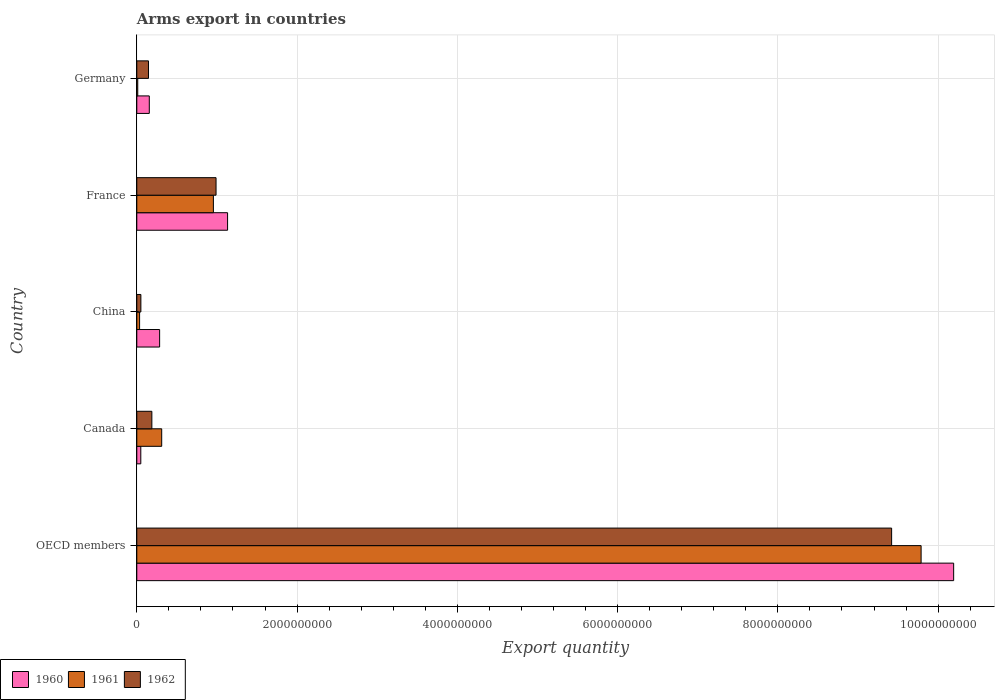How many different coloured bars are there?
Ensure brevity in your answer.  3. Are the number of bars on each tick of the Y-axis equal?
Keep it short and to the point. Yes. How many bars are there on the 1st tick from the bottom?
Provide a succinct answer. 3. In how many cases, is the number of bars for a given country not equal to the number of legend labels?
Ensure brevity in your answer.  0. What is the total arms export in 1960 in OECD members?
Your answer should be compact. 1.02e+1. Across all countries, what is the maximum total arms export in 1960?
Keep it short and to the point. 1.02e+1. Across all countries, what is the minimum total arms export in 1960?
Ensure brevity in your answer.  5.00e+07. In which country was the total arms export in 1962 maximum?
Give a very brief answer. OECD members. What is the total total arms export in 1960 in the graph?
Your response must be concise. 1.18e+1. What is the difference between the total arms export in 1962 in China and that in France?
Provide a short and direct response. -9.38e+08. What is the difference between the total arms export in 1962 in China and the total arms export in 1961 in France?
Your answer should be compact. -9.05e+08. What is the average total arms export in 1961 per country?
Your response must be concise. 2.22e+09. What is the difference between the total arms export in 1962 and total arms export in 1960 in China?
Provide a short and direct response. -2.34e+08. What is the ratio of the total arms export in 1960 in France to that in Germany?
Your answer should be very brief. 7.26. Is the difference between the total arms export in 1962 in Germany and OECD members greater than the difference between the total arms export in 1960 in Germany and OECD members?
Give a very brief answer. Yes. What is the difference between the highest and the second highest total arms export in 1961?
Your answer should be compact. 8.83e+09. What is the difference between the highest and the lowest total arms export in 1962?
Keep it short and to the point. 9.37e+09. In how many countries, is the total arms export in 1962 greater than the average total arms export in 1962 taken over all countries?
Keep it short and to the point. 1. Is the sum of the total arms export in 1960 in China and OECD members greater than the maximum total arms export in 1962 across all countries?
Your answer should be very brief. Yes. Is it the case that in every country, the sum of the total arms export in 1961 and total arms export in 1960 is greater than the total arms export in 1962?
Offer a terse response. Yes. What is the difference between two consecutive major ticks on the X-axis?
Keep it short and to the point. 2.00e+09. Are the values on the major ticks of X-axis written in scientific E-notation?
Make the answer very short. No. What is the title of the graph?
Provide a succinct answer. Arms export in countries. What is the label or title of the X-axis?
Your answer should be very brief. Export quantity. What is the label or title of the Y-axis?
Give a very brief answer. Country. What is the Export quantity in 1960 in OECD members?
Keep it short and to the point. 1.02e+1. What is the Export quantity of 1961 in OECD members?
Your response must be concise. 9.79e+09. What is the Export quantity of 1962 in OECD members?
Make the answer very short. 9.42e+09. What is the Export quantity of 1960 in Canada?
Your answer should be compact. 5.00e+07. What is the Export quantity of 1961 in Canada?
Offer a very short reply. 3.11e+08. What is the Export quantity of 1962 in Canada?
Give a very brief answer. 1.88e+08. What is the Export quantity in 1960 in China?
Ensure brevity in your answer.  2.85e+08. What is the Export quantity of 1961 in China?
Ensure brevity in your answer.  3.50e+07. What is the Export quantity of 1962 in China?
Your answer should be compact. 5.10e+07. What is the Export quantity in 1960 in France?
Keep it short and to the point. 1.13e+09. What is the Export quantity in 1961 in France?
Your response must be concise. 9.56e+08. What is the Export quantity of 1962 in France?
Your answer should be compact. 9.89e+08. What is the Export quantity of 1960 in Germany?
Your response must be concise. 1.56e+08. What is the Export quantity in 1961 in Germany?
Make the answer very short. 1.20e+07. What is the Export quantity of 1962 in Germany?
Ensure brevity in your answer.  1.46e+08. Across all countries, what is the maximum Export quantity in 1960?
Provide a succinct answer. 1.02e+1. Across all countries, what is the maximum Export quantity of 1961?
Your response must be concise. 9.79e+09. Across all countries, what is the maximum Export quantity in 1962?
Give a very brief answer. 9.42e+09. Across all countries, what is the minimum Export quantity of 1961?
Offer a very short reply. 1.20e+07. Across all countries, what is the minimum Export quantity in 1962?
Make the answer very short. 5.10e+07. What is the total Export quantity in 1960 in the graph?
Your response must be concise. 1.18e+1. What is the total Export quantity of 1961 in the graph?
Keep it short and to the point. 1.11e+1. What is the total Export quantity in 1962 in the graph?
Provide a succinct answer. 1.08e+1. What is the difference between the Export quantity of 1960 in OECD members and that in Canada?
Provide a succinct answer. 1.01e+1. What is the difference between the Export quantity of 1961 in OECD members and that in Canada?
Provide a succinct answer. 9.48e+09. What is the difference between the Export quantity of 1962 in OECD members and that in Canada?
Your answer should be very brief. 9.23e+09. What is the difference between the Export quantity in 1960 in OECD members and that in China?
Give a very brief answer. 9.91e+09. What is the difference between the Export quantity of 1961 in OECD members and that in China?
Make the answer very short. 9.75e+09. What is the difference between the Export quantity in 1962 in OECD members and that in China?
Your answer should be compact. 9.37e+09. What is the difference between the Export quantity in 1960 in OECD members and that in France?
Your answer should be very brief. 9.06e+09. What is the difference between the Export quantity of 1961 in OECD members and that in France?
Your answer should be compact. 8.83e+09. What is the difference between the Export quantity of 1962 in OECD members and that in France?
Ensure brevity in your answer.  8.43e+09. What is the difference between the Export quantity in 1960 in OECD members and that in Germany?
Your answer should be very brief. 1.00e+1. What is the difference between the Export quantity of 1961 in OECD members and that in Germany?
Provide a succinct answer. 9.78e+09. What is the difference between the Export quantity of 1962 in OECD members and that in Germany?
Provide a short and direct response. 9.27e+09. What is the difference between the Export quantity in 1960 in Canada and that in China?
Ensure brevity in your answer.  -2.35e+08. What is the difference between the Export quantity in 1961 in Canada and that in China?
Ensure brevity in your answer.  2.76e+08. What is the difference between the Export quantity in 1962 in Canada and that in China?
Keep it short and to the point. 1.37e+08. What is the difference between the Export quantity in 1960 in Canada and that in France?
Provide a succinct answer. -1.08e+09. What is the difference between the Export quantity of 1961 in Canada and that in France?
Give a very brief answer. -6.45e+08. What is the difference between the Export quantity of 1962 in Canada and that in France?
Make the answer very short. -8.01e+08. What is the difference between the Export quantity in 1960 in Canada and that in Germany?
Make the answer very short. -1.06e+08. What is the difference between the Export quantity of 1961 in Canada and that in Germany?
Ensure brevity in your answer.  2.99e+08. What is the difference between the Export quantity in 1962 in Canada and that in Germany?
Your answer should be compact. 4.20e+07. What is the difference between the Export quantity of 1960 in China and that in France?
Ensure brevity in your answer.  -8.48e+08. What is the difference between the Export quantity of 1961 in China and that in France?
Your answer should be compact. -9.21e+08. What is the difference between the Export quantity of 1962 in China and that in France?
Keep it short and to the point. -9.38e+08. What is the difference between the Export quantity of 1960 in China and that in Germany?
Offer a terse response. 1.29e+08. What is the difference between the Export quantity of 1961 in China and that in Germany?
Your answer should be very brief. 2.30e+07. What is the difference between the Export quantity of 1962 in China and that in Germany?
Make the answer very short. -9.50e+07. What is the difference between the Export quantity in 1960 in France and that in Germany?
Your answer should be very brief. 9.77e+08. What is the difference between the Export quantity of 1961 in France and that in Germany?
Your answer should be very brief. 9.44e+08. What is the difference between the Export quantity of 1962 in France and that in Germany?
Ensure brevity in your answer.  8.43e+08. What is the difference between the Export quantity of 1960 in OECD members and the Export quantity of 1961 in Canada?
Keep it short and to the point. 9.88e+09. What is the difference between the Export quantity of 1960 in OECD members and the Export quantity of 1962 in Canada?
Your response must be concise. 1.00e+1. What is the difference between the Export quantity of 1961 in OECD members and the Export quantity of 1962 in Canada?
Provide a short and direct response. 9.60e+09. What is the difference between the Export quantity of 1960 in OECD members and the Export quantity of 1961 in China?
Make the answer very short. 1.02e+1. What is the difference between the Export quantity in 1960 in OECD members and the Export quantity in 1962 in China?
Keep it short and to the point. 1.01e+1. What is the difference between the Export quantity in 1961 in OECD members and the Export quantity in 1962 in China?
Make the answer very short. 9.74e+09. What is the difference between the Export quantity in 1960 in OECD members and the Export quantity in 1961 in France?
Your answer should be very brief. 9.24e+09. What is the difference between the Export quantity of 1960 in OECD members and the Export quantity of 1962 in France?
Provide a succinct answer. 9.20e+09. What is the difference between the Export quantity in 1961 in OECD members and the Export quantity in 1962 in France?
Provide a short and direct response. 8.80e+09. What is the difference between the Export quantity in 1960 in OECD members and the Export quantity in 1961 in Germany?
Give a very brief answer. 1.02e+1. What is the difference between the Export quantity in 1960 in OECD members and the Export quantity in 1962 in Germany?
Your answer should be compact. 1.00e+1. What is the difference between the Export quantity in 1961 in OECD members and the Export quantity in 1962 in Germany?
Your answer should be very brief. 9.64e+09. What is the difference between the Export quantity in 1960 in Canada and the Export quantity in 1961 in China?
Provide a succinct answer. 1.50e+07. What is the difference between the Export quantity of 1961 in Canada and the Export quantity of 1962 in China?
Your answer should be compact. 2.60e+08. What is the difference between the Export quantity of 1960 in Canada and the Export quantity of 1961 in France?
Ensure brevity in your answer.  -9.06e+08. What is the difference between the Export quantity of 1960 in Canada and the Export quantity of 1962 in France?
Your answer should be very brief. -9.39e+08. What is the difference between the Export quantity in 1961 in Canada and the Export quantity in 1962 in France?
Ensure brevity in your answer.  -6.78e+08. What is the difference between the Export quantity in 1960 in Canada and the Export quantity in 1961 in Germany?
Make the answer very short. 3.80e+07. What is the difference between the Export quantity in 1960 in Canada and the Export quantity in 1962 in Germany?
Your response must be concise. -9.60e+07. What is the difference between the Export quantity in 1961 in Canada and the Export quantity in 1962 in Germany?
Offer a very short reply. 1.65e+08. What is the difference between the Export quantity in 1960 in China and the Export quantity in 1961 in France?
Provide a succinct answer. -6.71e+08. What is the difference between the Export quantity in 1960 in China and the Export quantity in 1962 in France?
Offer a very short reply. -7.04e+08. What is the difference between the Export quantity in 1961 in China and the Export quantity in 1962 in France?
Keep it short and to the point. -9.54e+08. What is the difference between the Export quantity in 1960 in China and the Export quantity in 1961 in Germany?
Provide a succinct answer. 2.73e+08. What is the difference between the Export quantity of 1960 in China and the Export quantity of 1962 in Germany?
Keep it short and to the point. 1.39e+08. What is the difference between the Export quantity of 1961 in China and the Export quantity of 1962 in Germany?
Your answer should be very brief. -1.11e+08. What is the difference between the Export quantity in 1960 in France and the Export quantity in 1961 in Germany?
Provide a short and direct response. 1.12e+09. What is the difference between the Export quantity in 1960 in France and the Export quantity in 1962 in Germany?
Your answer should be compact. 9.87e+08. What is the difference between the Export quantity in 1961 in France and the Export quantity in 1962 in Germany?
Offer a terse response. 8.10e+08. What is the average Export quantity in 1960 per country?
Your answer should be compact. 2.36e+09. What is the average Export quantity in 1961 per country?
Make the answer very short. 2.22e+09. What is the average Export quantity of 1962 per country?
Ensure brevity in your answer.  2.16e+09. What is the difference between the Export quantity of 1960 and Export quantity of 1961 in OECD members?
Your answer should be very brief. 4.06e+08. What is the difference between the Export quantity in 1960 and Export quantity in 1962 in OECD members?
Your answer should be very brief. 7.74e+08. What is the difference between the Export quantity of 1961 and Export quantity of 1962 in OECD members?
Provide a succinct answer. 3.68e+08. What is the difference between the Export quantity of 1960 and Export quantity of 1961 in Canada?
Offer a terse response. -2.61e+08. What is the difference between the Export quantity in 1960 and Export quantity in 1962 in Canada?
Give a very brief answer. -1.38e+08. What is the difference between the Export quantity of 1961 and Export quantity of 1962 in Canada?
Offer a very short reply. 1.23e+08. What is the difference between the Export quantity in 1960 and Export quantity in 1961 in China?
Provide a short and direct response. 2.50e+08. What is the difference between the Export quantity in 1960 and Export quantity in 1962 in China?
Keep it short and to the point. 2.34e+08. What is the difference between the Export quantity in 1961 and Export quantity in 1962 in China?
Your answer should be very brief. -1.60e+07. What is the difference between the Export quantity of 1960 and Export quantity of 1961 in France?
Offer a terse response. 1.77e+08. What is the difference between the Export quantity of 1960 and Export quantity of 1962 in France?
Your answer should be very brief. 1.44e+08. What is the difference between the Export quantity in 1961 and Export quantity in 1962 in France?
Keep it short and to the point. -3.30e+07. What is the difference between the Export quantity in 1960 and Export quantity in 1961 in Germany?
Ensure brevity in your answer.  1.44e+08. What is the difference between the Export quantity in 1960 and Export quantity in 1962 in Germany?
Your response must be concise. 1.00e+07. What is the difference between the Export quantity of 1961 and Export quantity of 1962 in Germany?
Your answer should be compact. -1.34e+08. What is the ratio of the Export quantity of 1960 in OECD members to that in Canada?
Your answer should be very brief. 203.88. What is the ratio of the Export quantity in 1961 in OECD members to that in Canada?
Give a very brief answer. 31.47. What is the ratio of the Export quantity of 1962 in OECD members to that in Canada?
Offer a very short reply. 50.11. What is the ratio of the Export quantity of 1960 in OECD members to that in China?
Keep it short and to the point. 35.77. What is the ratio of the Export quantity of 1961 in OECD members to that in China?
Offer a terse response. 279.66. What is the ratio of the Export quantity in 1962 in OECD members to that in China?
Provide a succinct answer. 184.71. What is the ratio of the Export quantity in 1960 in OECD members to that in France?
Give a very brief answer. 9. What is the ratio of the Export quantity of 1961 in OECD members to that in France?
Offer a very short reply. 10.24. What is the ratio of the Export quantity in 1962 in OECD members to that in France?
Make the answer very short. 9.52. What is the ratio of the Export quantity in 1960 in OECD members to that in Germany?
Keep it short and to the point. 65.35. What is the ratio of the Export quantity in 1961 in OECD members to that in Germany?
Give a very brief answer. 815.67. What is the ratio of the Export quantity in 1962 in OECD members to that in Germany?
Your answer should be compact. 64.52. What is the ratio of the Export quantity of 1960 in Canada to that in China?
Provide a succinct answer. 0.18. What is the ratio of the Export quantity in 1961 in Canada to that in China?
Make the answer very short. 8.89. What is the ratio of the Export quantity of 1962 in Canada to that in China?
Offer a terse response. 3.69. What is the ratio of the Export quantity of 1960 in Canada to that in France?
Provide a short and direct response. 0.04. What is the ratio of the Export quantity of 1961 in Canada to that in France?
Offer a terse response. 0.33. What is the ratio of the Export quantity in 1962 in Canada to that in France?
Ensure brevity in your answer.  0.19. What is the ratio of the Export quantity in 1960 in Canada to that in Germany?
Offer a terse response. 0.32. What is the ratio of the Export quantity in 1961 in Canada to that in Germany?
Your response must be concise. 25.92. What is the ratio of the Export quantity of 1962 in Canada to that in Germany?
Make the answer very short. 1.29. What is the ratio of the Export quantity of 1960 in China to that in France?
Offer a terse response. 0.25. What is the ratio of the Export quantity in 1961 in China to that in France?
Give a very brief answer. 0.04. What is the ratio of the Export quantity of 1962 in China to that in France?
Your answer should be very brief. 0.05. What is the ratio of the Export quantity in 1960 in China to that in Germany?
Provide a short and direct response. 1.83. What is the ratio of the Export quantity of 1961 in China to that in Germany?
Ensure brevity in your answer.  2.92. What is the ratio of the Export quantity in 1962 in China to that in Germany?
Ensure brevity in your answer.  0.35. What is the ratio of the Export quantity in 1960 in France to that in Germany?
Your answer should be very brief. 7.26. What is the ratio of the Export quantity of 1961 in France to that in Germany?
Make the answer very short. 79.67. What is the ratio of the Export quantity of 1962 in France to that in Germany?
Give a very brief answer. 6.77. What is the difference between the highest and the second highest Export quantity of 1960?
Your answer should be very brief. 9.06e+09. What is the difference between the highest and the second highest Export quantity of 1961?
Keep it short and to the point. 8.83e+09. What is the difference between the highest and the second highest Export quantity in 1962?
Keep it short and to the point. 8.43e+09. What is the difference between the highest and the lowest Export quantity in 1960?
Make the answer very short. 1.01e+1. What is the difference between the highest and the lowest Export quantity of 1961?
Your answer should be very brief. 9.78e+09. What is the difference between the highest and the lowest Export quantity in 1962?
Give a very brief answer. 9.37e+09. 